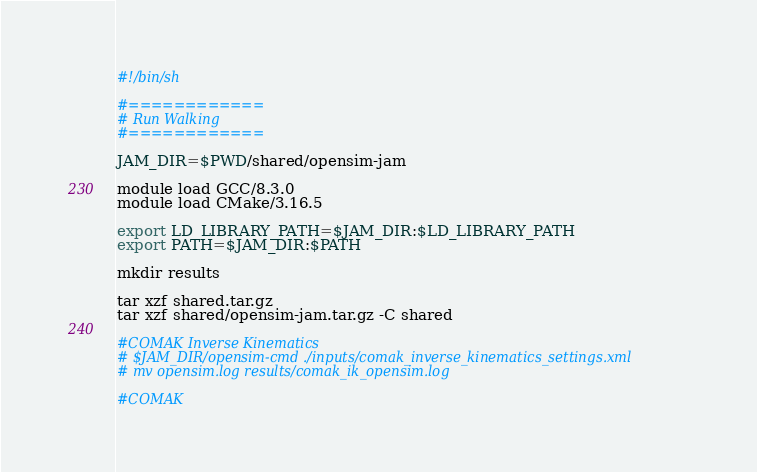<code> <loc_0><loc_0><loc_500><loc_500><_Bash_>#!/bin/sh

#============
# Run Walking
#============

JAM_DIR=$PWD/shared/opensim-jam

module load GCC/8.3.0
module load CMake/3.16.5

export LD_LIBRARY_PATH=$JAM_DIR:$LD_LIBRARY_PATH
export PATH=$JAM_DIR:$PATH

mkdir results

tar xzf shared.tar.gz
tar xzf shared/opensim-jam.tar.gz -C shared

#COMAK Inverse Kinematics
# $JAM_DIR/opensim-cmd ./inputs/comak_inverse_kinematics_settings.xml
# mv opensim.log results/comak_ik_opensim.log

#COMAK</code> 